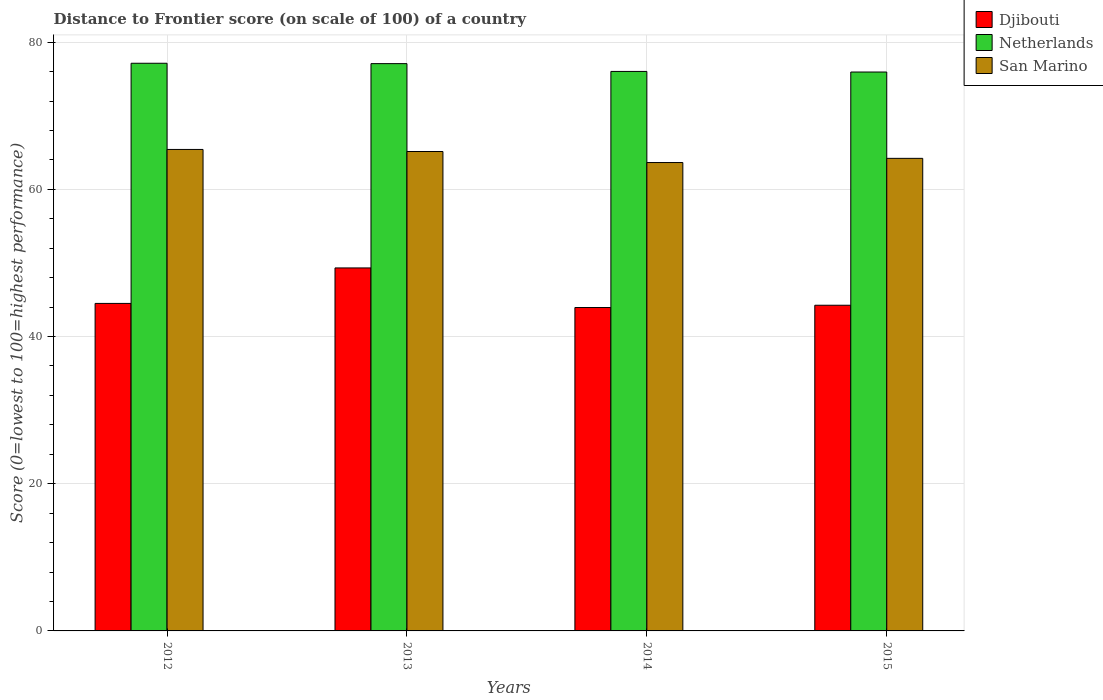How many groups of bars are there?
Provide a succinct answer. 4. Are the number of bars per tick equal to the number of legend labels?
Offer a very short reply. Yes. How many bars are there on the 1st tick from the left?
Your response must be concise. 3. How many bars are there on the 2nd tick from the right?
Make the answer very short. 3. What is the distance to frontier score of in Netherlands in 2015?
Give a very brief answer. 75.94. Across all years, what is the maximum distance to frontier score of in San Marino?
Ensure brevity in your answer.  65.42. Across all years, what is the minimum distance to frontier score of in Netherlands?
Offer a very short reply. 75.94. In which year was the distance to frontier score of in Djibouti maximum?
Ensure brevity in your answer.  2013. In which year was the distance to frontier score of in Djibouti minimum?
Provide a succinct answer. 2014. What is the total distance to frontier score of in Netherlands in the graph?
Your answer should be compact. 306.17. What is the difference between the distance to frontier score of in Netherlands in 2012 and that in 2015?
Ensure brevity in your answer.  1.19. What is the difference between the distance to frontier score of in Djibouti in 2015 and the distance to frontier score of in San Marino in 2012?
Your answer should be very brief. -21.17. What is the average distance to frontier score of in Djibouti per year?
Provide a short and direct response. 45.5. In the year 2013, what is the difference between the distance to frontier score of in Netherlands and distance to frontier score of in San Marino?
Provide a short and direct response. 11.94. In how many years, is the distance to frontier score of in Djibouti greater than 12?
Give a very brief answer. 4. What is the ratio of the distance to frontier score of in Djibouti in 2012 to that in 2013?
Provide a succinct answer. 0.9. What is the difference between the highest and the second highest distance to frontier score of in Djibouti?
Your response must be concise. 4.82. What is the difference between the highest and the lowest distance to frontier score of in San Marino?
Make the answer very short. 1.78. In how many years, is the distance to frontier score of in San Marino greater than the average distance to frontier score of in San Marino taken over all years?
Keep it short and to the point. 2. What does the 3rd bar from the left in 2012 represents?
Your answer should be very brief. San Marino. Is it the case that in every year, the sum of the distance to frontier score of in Netherlands and distance to frontier score of in San Marino is greater than the distance to frontier score of in Djibouti?
Offer a very short reply. Yes. What is the difference between two consecutive major ticks on the Y-axis?
Make the answer very short. 20. Does the graph contain any zero values?
Ensure brevity in your answer.  No. How many legend labels are there?
Provide a short and direct response. 3. How are the legend labels stacked?
Give a very brief answer. Vertical. What is the title of the graph?
Your answer should be compact. Distance to Frontier score (on scale of 100) of a country. What is the label or title of the X-axis?
Offer a very short reply. Years. What is the label or title of the Y-axis?
Offer a terse response. Score (0=lowest to 100=highest performance). What is the Score (0=lowest to 100=highest performance) in Djibouti in 2012?
Offer a very short reply. 44.5. What is the Score (0=lowest to 100=highest performance) in Netherlands in 2012?
Make the answer very short. 77.13. What is the Score (0=lowest to 100=highest performance) of San Marino in 2012?
Provide a succinct answer. 65.42. What is the Score (0=lowest to 100=highest performance) in Djibouti in 2013?
Keep it short and to the point. 49.32. What is the Score (0=lowest to 100=highest performance) in Netherlands in 2013?
Provide a short and direct response. 77.08. What is the Score (0=lowest to 100=highest performance) in San Marino in 2013?
Your answer should be very brief. 65.14. What is the Score (0=lowest to 100=highest performance) of Djibouti in 2014?
Your answer should be very brief. 43.94. What is the Score (0=lowest to 100=highest performance) of Netherlands in 2014?
Keep it short and to the point. 76.02. What is the Score (0=lowest to 100=highest performance) of San Marino in 2014?
Give a very brief answer. 63.64. What is the Score (0=lowest to 100=highest performance) of Djibouti in 2015?
Ensure brevity in your answer.  44.25. What is the Score (0=lowest to 100=highest performance) of Netherlands in 2015?
Offer a terse response. 75.94. What is the Score (0=lowest to 100=highest performance) of San Marino in 2015?
Make the answer very short. 64.21. Across all years, what is the maximum Score (0=lowest to 100=highest performance) of Djibouti?
Give a very brief answer. 49.32. Across all years, what is the maximum Score (0=lowest to 100=highest performance) in Netherlands?
Your response must be concise. 77.13. Across all years, what is the maximum Score (0=lowest to 100=highest performance) in San Marino?
Give a very brief answer. 65.42. Across all years, what is the minimum Score (0=lowest to 100=highest performance) of Djibouti?
Offer a very short reply. 43.94. Across all years, what is the minimum Score (0=lowest to 100=highest performance) in Netherlands?
Offer a very short reply. 75.94. Across all years, what is the minimum Score (0=lowest to 100=highest performance) in San Marino?
Offer a terse response. 63.64. What is the total Score (0=lowest to 100=highest performance) in Djibouti in the graph?
Offer a terse response. 182.01. What is the total Score (0=lowest to 100=highest performance) of Netherlands in the graph?
Your answer should be very brief. 306.17. What is the total Score (0=lowest to 100=highest performance) of San Marino in the graph?
Your answer should be very brief. 258.41. What is the difference between the Score (0=lowest to 100=highest performance) in Djibouti in 2012 and that in 2013?
Your answer should be very brief. -4.82. What is the difference between the Score (0=lowest to 100=highest performance) in Netherlands in 2012 and that in 2013?
Provide a succinct answer. 0.05. What is the difference between the Score (0=lowest to 100=highest performance) in San Marino in 2012 and that in 2013?
Make the answer very short. 0.28. What is the difference between the Score (0=lowest to 100=highest performance) in Djibouti in 2012 and that in 2014?
Provide a succinct answer. 0.56. What is the difference between the Score (0=lowest to 100=highest performance) in Netherlands in 2012 and that in 2014?
Your answer should be compact. 1.11. What is the difference between the Score (0=lowest to 100=highest performance) of San Marino in 2012 and that in 2014?
Provide a short and direct response. 1.78. What is the difference between the Score (0=lowest to 100=highest performance) of Netherlands in 2012 and that in 2015?
Ensure brevity in your answer.  1.19. What is the difference between the Score (0=lowest to 100=highest performance) of San Marino in 2012 and that in 2015?
Provide a short and direct response. 1.21. What is the difference between the Score (0=lowest to 100=highest performance) in Djibouti in 2013 and that in 2014?
Keep it short and to the point. 5.38. What is the difference between the Score (0=lowest to 100=highest performance) in Netherlands in 2013 and that in 2014?
Give a very brief answer. 1.06. What is the difference between the Score (0=lowest to 100=highest performance) of San Marino in 2013 and that in 2014?
Offer a very short reply. 1.5. What is the difference between the Score (0=lowest to 100=highest performance) in Djibouti in 2013 and that in 2015?
Make the answer very short. 5.07. What is the difference between the Score (0=lowest to 100=highest performance) of Netherlands in 2013 and that in 2015?
Ensure brevity in your answer.  1.14. What is the difference between the Score (0=lowest to 100=highest performance) of Djibouti in 2014 and that in 2015?
Make the answer very short. -0.31. What is the difference between the Score (0=lowest to 100=highest performance) of Netherlands in 2014 and that in 2015?
Your response must be concise. 0.08. What is the difference between the Score (0=lowest to 100=highest performance) in San Marino in 2014 and that in 2015?
Make the answer very short. -0.57. What is the difference between the Score (0=lowest to 100=highest performance) in Djibouti in 2012 and the Score (0=lowest to 100=highest performance) in Netherlands in 2013?
Your response must be concise. -32.58. What is the difference between the Score (0=lowest to 100=highest performance) in Djibouti in 2012 and the Score (0=lowest to 100=highest performance) in San Marino in 2013?
Offer a very short reply. -20.64. What is the difference between the Score (0=lowest to 100=highest performance) of Netherlands in 2012 and the Score (0=lowest to 100=highest performance) of San Marino in 2013?
Provide a short and direct response. 11.99. What is the difference between the Score (0=lowest to 100=highest performance) in Djibouti in 2012 and the Score (0=lowest to 100=highest performance) in Netherlands in 2014?
Give a very brief answer. -31.52. What is the difference between the Score (0=lowest to 100=highest performance) in Djibouti in 2012 and the Score (0=lowest to 100=highest performance) in San Marino in 2014?
Your response must be concise. -19.14. What is the difference between the Score (0=lowest to 100=highest performance) of Netherlands in 2012 and the Score (0=lowest to 100=highest performance) of San Marino in 2014?
Your answer should be compact. 13.49. What is the difference between the Score (0=lowest to 100=highest performance) in Djibouti in 2012 and the Score (0=lowest to 100=highest performance) in Netherlands in 2015?
Keep it short and to the point. -31.44. What is the difference between the Score (0=lowest to 100=highest performance) in Djibouti in 2012 and the Score (0=lowest to 100=highest performance) in San Marino in 2015?
Provide a succinct answer. -19.71. What is the difference between the Score (0=lowest to 100=highest performance) in Netherlands in 2012 and the Score (0=lowest to 100=highest performance) in San Marino in 2015?
Offer a very short reply. 12.92. What is the difference between the Score (0=lowest to 100=highest performance) of Djibouti in 2013 and the Score (0=lowest to 100=highest performance) of Netherlands in 2014?
Provide a succinct answer. -26.7. What is the difference between the Score (0=lowest to 100=highest performance) in Djibouti in 2013 and the Score (0=lowest to 100=highest performance) in San Marino in 2014?
Your answer should be very brief. -14.32. What is the difference between the Score (0=lowest to 100=highest performance) in Netherlands in 2013 and the Score (0=lowest to 100=highest performance) in San Marino in 2014?
Ensure brevity in your answer.  13.44. What is the difference between the Score (0=lowest to 100=highest performance) in Djibouti in 2013 and the Score (0=lowest to 100=highest performance) in Netherlands in 2015?
Give a very brief answer. -26.62. What is the difference between the Score (0=lowest to 100=highest performance) of Djibouti in 2013 and the Score (0=lowest to 100=highest performance) of San Marino in 2015?
Provide a succinct answer. -14.89. What is the difference between the Score (0=lowest to 100=highest performance) of Netherlands in 2013 and the Score (0=lowest to 100=highest performance) of San Marino in 2015?
Your answer should be compact. 12.87. What is the difference between the Score (0=lowest to 100=highest performance) in Djibouti in 2014 and the Score (0=lowest to 100=highest performance) in Netherlands in 2015?
Offer a terse response. -32. What is the difference between the Score (0=lowest to 100=highest performance) of Djibouti in 2014 and the Score (0=lowest to 100=highest performance) of San Marino in 2015?
Provide a succinct answer. -20.27. What is the difference between the Score (0=lowest to 100=highest performance) of Netherlands in 2014 and the Score (0=lowest to 100=highest performance) of San Marino in 2015?
Give a very brief answer. 11.81. What is the average Score (0=lowest to 100=highest performance) in Djibouti per year?
Give a very brief answer. 45.5. What is the average Score (0=lowest to 100=highest performance) of Netherlands per year?
Offer a very short reply. 76.54. What is the average Score (0=lowest to 100=highest performance) in San Marino per year?
Provide a succinct answer. 64.6. In the year 2012, what is the difference between the Score (0=lowest to 100=highest performance) of Djibouti and Score (0=lowest to 100=highest performance) of Netherlands?
Provide a short and direct response. -32.63. In the year 2012, what is the difference between the Score (0=lowest to 100=highest performance) in Djibouti and Score (0=lowest to 100=highest performance) in San Marino?
Give a very brief answer. -20.92. In the year 2012, what is the difference between the Score (0=lowest to 100=highest performance) of Netherlands and Score (0=lowest to 100=highest performance) of San Marino?
Give a very brief answer. 11.71. In the year 2013, what is the difference between the Score (0=lowest to 100=highest performance) of Djibouti and Score (0=lowest to 100=highest performance) of Netherlands?
Offer a terse response. -27.76. In the year 2013, what is the difference between the Score (0=lowest to 100=highest performance) in Djibouti and Score (0=lowest to 100=highest performance) in San Marino?
Your answer should be compact. -15.82. In the year 2013, what is the difference between the Score (0=lowest to 100=highest performance) of Netherlands and Score (0=lowest to 100=highest performance) of San Marino?
Your answer should be very brief. 11.94. In the year 2014, what is the difference between the Score (0=lowest to 100=highest performance) in Djibouti and Score (0=lowest to 100=highest performance) in Netherlands?
Offer a very short reply. -32.08. In the year 2014, what is the difference between the Score (0=lowest to 100=highest performance) in Djibouti and Score (0=lowest to 100=highest performance) in San Marino?
Your response must be concise. -19.7. In the year 2014, what is the difference between the Score (0=lowest to 100=highest performance) of Netherlands and Score (0=lowest to 100=highest performance) of San Marino?
Make the answer very short. 12.38. In the year 2015, what is the difference between the Score (0=lowest to 100=highest performance) of Djibouti and Score (0=lowest to 100=highest performance) of Netherlands?
Ensure brevity in your answer.  -31.69. In the year 2015, what is the difference between the Score (0=lowest to 100=highest performance) of Djibouti and Score (0=lowest to 100=highest performance) of San Marino?
Make the answer very short. -19.96. In the year 2015, what is the difference between the Score (0=lowest to 100=highest performance) of Netherlands and Score (0=lowest to 100=highest performance) of San Marino?
Make the answer very short. 11.73. What is the ratio of the Score (0=lowest to 100=highest performance) of Djibouti in 2012 to that in 2013?
Your answer should be compact. 0.9. What is the ratio of the Score (0=lowest to 100=highest performance) in Netherlands in 2012 to that in 2013?
Keep it short and to the point. 1. What is the ratio of the Score (0=lowest to 100=highest performance) of Djibouti in 2012 to that in 2014?
Ensure brevity in your answer.  1.01. What is the ratio of the Score (0=lowest to 100=highest performance) of Netherlands in 2012 to that in 2014?
Give a very brief answer. 1.01. What is the ratio of the Score (0=lowest to 100=highest performance) in San Marino in 2012 to that in 2014?
Ensure brevity in your answer.  1.03. What is the ratio of the Score (0=lowest to 100=highest performance) of Djibouti in 2012 to that in 2015?
Keep it short and to the point. 1.01. What is the ratio of the Score (0=lowest to 100=highest performance) of Netherlands in 2012 to that in 2015?
Ensure brevity in your answer.  1.02. What is the ratio of the Score (0=lowest to 100=highest performance) in San Marino in 2012 to that in 2015?
Offer a terse response. 1.02. What is the ratio of the Score (0=lowest to 100=highest performance) of Djibouti in 2013 to that in 2014?
Offer a very short reply. 1.12. What is the ratio of the Score (0=lowest to 100=highest performance) of Netherlands in 2013 to that in 2014?
Provide a succinct answer. 1.01. What is the ratio of the Score (0=lowest to 100=highest performance) of San Marino in 2013 to that in 2014?
Your response must be concise. 1.02. What is the ratio of the Score (0=lowest to 100=highest performance) of Djibouti in 2013 to that in 2015?
Provide a succinct answer. 1.11. What is the ratio of the Score (0=lowest to 100=highest performance) in Netherlands in 2013 to that in 2015?
Make the answer very short. 1.01. What is the ratio of the Score (0=lowest to 100=highest performance) in San Marino in 2013 to that in 2015?
Your answer should be very brief. 1.01. What is the ratio of the Score (0=lowest to 100=highest performance) of San Marino in 2014 to that in 2015?
Keep it short and to the point. 0.99. What is the difference between the highest and the second highest Score (0=lowest to 100=highest performance) in Djibouti?
Make the answer very short. 4.82. What is the difference between the highest and the second highest Score (0=lowest to 100=highest performance) of Netherlands?
Keep it short and to the point. 0.05. What is the difference between the highest and the second highest Score (0=lowest to 100=highest performance) in San Marino?
Provide a short and direct response. 0.28. What is the difference between the highest and the lowest Score (0=lowest to 100=highest performance) of Djibouti?
Ensure brevity in your answer.  5.38. What is the difference between the highest and the lowest Score (0=lowest to 100=highest performance) in Netherlands?
Ensure brevity in your answer.  1.19. What is the difference between the highest and the lowest Score (0=lowest to 100=highest performance) in San Marino?
Your answer should be compact. 1.78. 